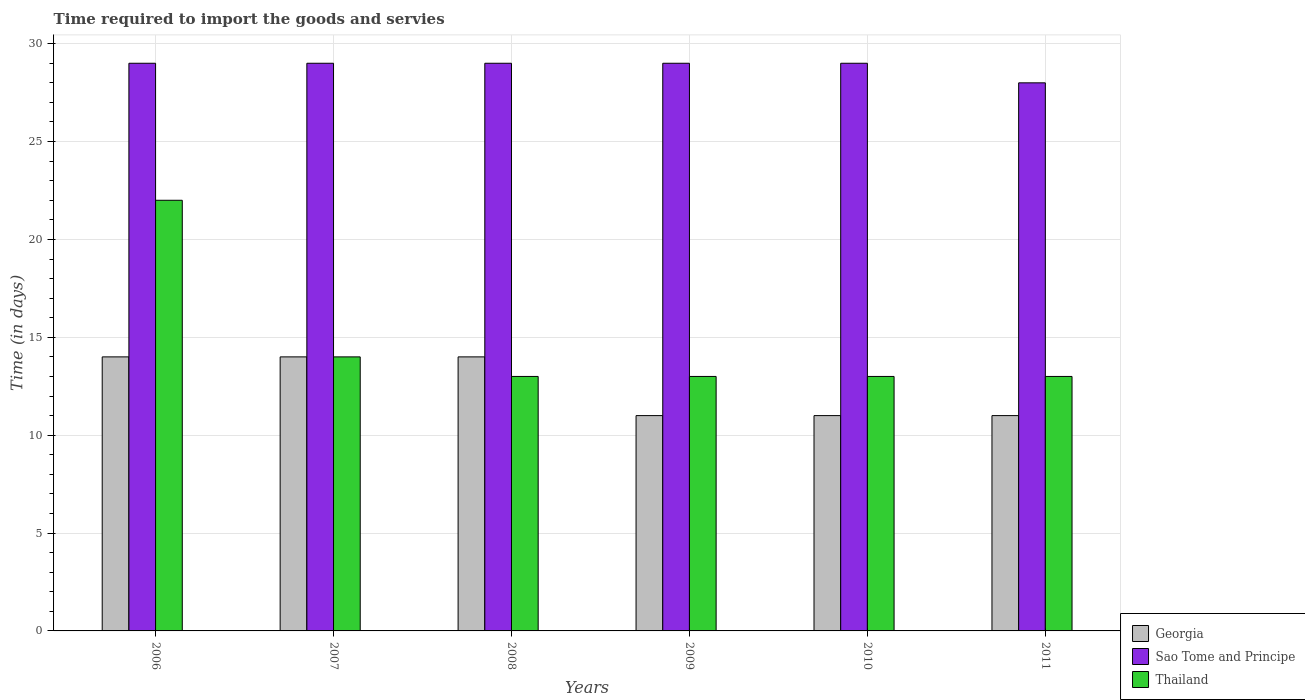How many different coloured bars are there?
Keep it short and to the point. 3. What is the label of the 4th group of bars from the left?
Make the answer very short. 2009. What is the number of days required to import the goods and services in Sao Tome and Principe in 2008?
Offer a very short reply. 29. Across all years, what is the maximum number of days required to import the goods and services in Thailand?
Keep it short and to the point. 22. Across all years, what is the minimum number of days required to import the goods and services in Thailand?
Your answer should be very brief. 13. What is the total number of days required to import the goods and services in Georgia in the graph?
Provide a short and direct response. 75. What is the difference between the number of days required to import the goods and services in Sao Tome and Principe in 2010 and that in 2011?
Your response must be concise. 1. What is the difference between the number of days required to import the goods and services in Sao Tome and Principe in 2011 and the number of days required to import the goods and services in Thailand in 2007?
Provide a short and direct response. 14. What is the average number of days required to import the goods and services in Thailand per year?
Your answer should be compact. 14.67. In the year 2010, what is the difference between the number of days required to import the goods and services in Georgia and number of days required to import the goods and services in Thailand?
Provide a succinct answer. -2. Is the number of days required to import the goods and services in Georgia in 2010 less than that in 2011?
Provide a short and direct response. No. Is the difference between the number of days required to import the goods and services in Georgia in 2008 and 2010 greater than the difference between the number of days required to import the goods and services in Thailand in 2008 and 2010?
Provide a succinct answer. Yes. What is the difference between the highest and the second highest number of days required to import the goods and services in Georgia?
Your answer should be compact. 0. What is the difference between the highest and the lowest number of days required to import the goods and services in Georgia?
Offer a terse response. 3. In how many years, is the number of days required to import the goods and services in Sao Tome and Principe greater than the average number of days required to import the goods and services in Sao Tome and Principe taken over all years?
Give a very brief answer. 5. Is the sum of the number of days required to import the goods and services in Sao Tome and Principe in 2006 and 2010 greater than the maximum number of days required to import the goods and services in Thailand across all years?
Keep it short and to the point. Yes. What does the 1st bar from the left in 2006 represents?
Your response must be concise. Georgia. What does the 2nd bar from the right in 2009 represents?
Offer a terse response. Sao Tome and Principe. How many years are there in the graph?
Your response must be concise. 6. What is the difference between two consecutive major ticks on the Y-axis?
Provide a succinct answer. 5. Does the graph contain grids?
Make the answer very short. Yes. Where does the legend appear in the graph?
Keep it short and to the point. Bottom right. How many legend labels are there?
Your answer should be very brief. 3. How are the legend labels stacked?
Your answer should be compact. Vertical. What is the title of the graph?
Offer a terse response. Time required to import the goods and servies. Does "Andorra" appear as one of the legend labels in the graph?
Provide a short and direct response. No. What is the label or title of the Y-axis?
Your answer should be very brief. Time (in days). What is the Time (in days) of Georgia in 2006?
Offer a very short reply. 14. What is the Time (in days) in Sao Tome and Principe in 2006?
Give a very brief answer. 29. What is the Time (in days) of Thailand in 2006?
Keep it short and to the point. 22. What is the Time (in days) of Thailand in 2008?
Give a very brief answer. 13. What is the Time (in days) of Sao Tome and Principe in 2009?
Give a very brief answer. 29. What is the Time (in days) in Sao Tome and Principe in 2010?
Give a very brief answer. 29. What is the Time (in days) of Thailand in 2010?
Provide a short and direct response. 13. What is the Time (in days) of Thailand in 2011?
Ensure brevity in your answer.  13. Across all years, what is the maximum Time (in days) of Sao Tome and Principe?
Provide a succinct answer. 29. Across all years, what is the maximum Time (in days) of Thailand?
Your answer should be compact. 22. Across all years, what is the minimum Time (in days) in Sao Tome and Principe?
Offer a very short reply. 28. What is the total Time (in days) of Sao Tome and Principe in the graph?
Provide a succinct answer. 173. What is the total Time (in days) in Thailand in the graph?
Your answer should be very brief. 88. What is the difference between the Time (in days) of Georgia in 2006 and that in 2008?
Make the answer very short. 0. What is the difference between the Time (in days) of Sao Tome and Principe in 2006 and that in 2008?
Keep it short and to the point. 0. What is the difference between the Time (in days) of Thailand in 2006 and that in 2008?
Offer a terse response. 9. What is the difference between the Time (in days) in Thailand in 2006 and that in 2010?
Offer a terse response. 9. What is the difference between the Time (in days) of Georgia in 2006 and that in 2011?
Your response must be concise. 3. What is the difference between the Time (in days) of Sao Tome and Principe in 2006 and that in 2011?
Give a very brief answer. 1. What is the difference between the Time (in days) of Georgia in 2007 and that in 2008?
Provide a short and direct response. 0. What is the difference between the Time (in days) in Sao Tome and Principe in 2007 and that in 2008?
Make the answer very short. 0. What is the difference between the Time (in days) of Thailand in 2007 and that in 2008?
Your answer should be compact. 1. What is the difference between the Time (in days) of Georgia in 2007 and that in 2009?
Your response must be concise. 3. What is the difference between the Time (in days) of Sao Tome and Principe in 2007 and that in 2009?
Give a very brief answer. 0. What is the difference between the Time (in days) in Georgia in 2007 and that in 2010?
Make the answer very short. 3. What is the difference between the Time (in days) of Thailand in 2007 and that in 2010?
Offer a terse response. 1. What is the difference between the Time (in days) of Georgia in 2007 and that in 2011?
Offer a terse response. 3. What is the difference between the Time (in days) of Sao Tome and Principe in 2007 and that in 2011?
Your answer should be compact. 1. What is the difference between the Time (in days) of Georgia in 2008 and that in 2009?
Your response must be concise. 3. What is the difference between the Time (in days) of Sao Tome and Principe in 2008 and that in 2009?
Make the answer very short. 0. What is the difference between the Time (in days) of Thailand in 2008 and that in 2009?
Your answer should be very brief. 0. What is the difference between the Time (in days) in Sao Tome and Principe in 2008 and that in 2010?
Ensure brevity in your answer.  0. What is the difference between the Time (in days) in Thailand in 2008 and that in 2010?
Give a very brief answer. 0. What is the difference between the Time (in days) of Sao Tome and Principe in 2008 and that in 2011?
Your response must be concise. 1. What is the difference between the Time (in days) of Thailand in 2008 and that in 2011?
Make the answer very short. 0. What is the difference between the Time (in days) in Sao Tome and Principe in 2009 and that in 2010?
Keep it short and to the point. 0. What is the difference between the Time (in days) of Georgia in 2009 and that in 2011?
Give a very brief answer. 0. What is the difference between the Time (in days) in Sao Tome and Principe in 2009 and that in 2011?
Your answer should be compact. 1. What is the difference between the Time (in days) in Thailand in 2009 and that in 2011?
Your response must be concise. 0. What is the difference between the Time (in days) of Sao Tome and Principe in 2010 and that in 2011?
Ensure brevity in your answer.  1. What is the difference between the Time (in days) in Georgia in 2006 and the Time (in days) in Thailand in 2008?
Provide a short and direct response. 1. What is the difference between the Time (in days) in Sao Tome and Principe in 2006 and the Time (in days) in Thailand in 2009?
Make the answer very short. 16. What is the difference between the Time (in days) of Sao Tome and Principe in 2006 and the Time (in days) of Thailand in 2010?
Provide a short and direct response. 16. What is the difference between the Time (in days) in Georgia in 2006 and the Time (in days) in Sao Tome and Principe in 2011?
Keep it short and to the point. -14. What is the difference between the Time (in days) of Georgia in 2007 and the Time (in days) of Sao Tome and Principe in 2008?
Provide a short and direct response. -15. What is the difference between the Time (in days) in Sao Tome and Principe in 2007 and the Time (in days) in Thailand in 2009?
Your answer should be compact. 16. What is the difference between the Time (in days) in Georgia in 2007 and the Time (in days) in Thailand in 2010?
Ensure brevity in your answer.  1. What is the difference between the Time (in days) in Sao Tome and Principe in 2007 and the Time (in days) in Thailand in 2010?
Your answer should be very brief. 16. What is the difference between the Time (in days) of Sao Tome and Principe in 2007 and the Time (in days) of Thailand in 2011?
Provide a short and direct response. 16. What is the difference between the Time (in days) in Georgia in 2008 and the Time (in days) in Sao Tome and Principe in 2009?
Offer a very short reply. -15. What is the difference between the Time (in days) of Georgia in 2008 and the Time (in days) of Sao Tome and Principe in 2010?
Make the answer very short. -15. What is the difference between the Time (in days) of Sao Tome and Principe in 2008 and the Time (in days) of Thailand in 2010?
Your answer should be compact. 16. What is the difference between the Time (in days) in Georgia in 2008 and the Time (in days) in Sao Tome and Principe in 2011?
Make the answer very short. -14. What is the difference between the Time (in days) in Georgia in 2008 and the Time (in days) in Thailand in 2011?
Your answer should be compact. 1. What is the difference between the Time (in days) of Georgia in 2009 and the Time (in days) of Sao Tome and Principe in 2010?
Your answer should be compact. -18. What is the difference between the Time (in days) of Georgia in 2009 and the Time (in days) of Thailand in 2010?
Offer a terse response. -2. What is the difference between the Time (in days) of Georgia in 2009 and the Time (in days) of Sao Tome and Principe in 2011?
Ensure brevity in your answer.  -17. What is the difference between the Time (in days) of Sao Tome and Principe in 2009 and the Time (in days) of Thailand in 2011?
Provide a short and direct response. 16. What is the difference between the Time (in days) of Sao Tome and Principe in 2010 and the Time (in days) of Thailand in 2011?
Give a very brief answer. 16. What is the average Time (in days) in Sao Tome and Principe per year?
Your response must be concise. 28.83. What is the average Time (in days) in Thailand per year?
Your answer should be very brief. 14.67. In the year 2006, what is the difference between the Time (in days) in Georgia and Time (in days) in Sao Tome and Principe?
Offer a terse response. -15. In the year 2007, what is the difference between the Time (in days) in Georgia and Time (in days) in Thailand?
Your answer should be very brief. 0. In the year 2008, what is the difference between the Time (in days) in Georgia and Time (in days) in Thailand?
Offer a terse response. 1. In the year 2009, what is the difference between the Time (in days) of Georgia and Time (in days) of Sao Tome and Principe?
Provide a short and direct response. -18. In the year 2010, what is the difference between the Time (in days) in Sao Tome and Principe and Time (in days) in Thailand?
Offer a terse response. 16. In the year 2011, what is the difference between the Time (in days) of Georgia and Time (in days) of Sao Tome and Principe?
Keep it short and to the point. -17. What is the ratio of the Time (in days) of Thailand in 2006 to that in 2007?
Your answer should be very brief. 1.57. What is the ratio of the Time (in days) in Georgia in 2006 to that in 2008?
Provide a succinct answer. 1. What is the ratio of the Time (in days) in Sao Tome and Principe in 2006 to that in 2008?
Your answer should be compact. 1. What is the ratio of the Time (in days) of Thailand in 2006 to that in 2008?
Give a very brief answer. 1.69. What is the ratio of the Time (in days) in Georgia in 2006 to that in 2009?
Your answer should be very brief. 1.27. What is the ratio of the Time (in days) in Thailand in 2006 to that in 2009?
Provide a succinct answer. 1.69. What is the ratio of the Time (in days) in Georgia in 2006 to that in 2010?
Offer a terse response. 1.27. What is the ratio of the Time (in days) of Sao Tome and Principe in 2006 to that in 2010?
Your response must be concise. 1. What is the ratio of the Time (in days) in Thailand in 2006 to that in 2010?
Your answer should be compact. 1.69. What is the ratio of the Time (in days) of Georgia in 2006 to that in 2011?
Your answer should be very brief. 1.27. What is the ratio of the Time (in days) in Sao Tome and Principe in 2006 to that in 2011?
Provide a short and direct response. 1.04. What is the ratio of the Time (in days) of Thailand in 2006 to that in 2011?
Provide a succinct answer. 1.69. What is the ratio of the Time (in days) of Georgia in 2007 to that in 2008?
Ensure brevity in your answer.  1. What is the ratio of the Time (in days) in Sao Tome and Principe in 2007 to that in 2008?
Provide a short and direct response. 1. What is the ratio of the Time (in days) of Thailand in 2007 to that in 2008?
Provide a succinct answer. 1.08. What is the ratio of the Time (in days) in Georgia in 2007 to that in 2009?
Offer a very short reply. 1.27. What is the ratio of the Time (in days) of Sao Tome and Principe in 2007 to that in 2009?
Give a very brief answer. 1. What is the ratio of the Time (in days) of Thailand in 2007 to that in 2009?
Your response must be concise. 1.08. What is the ratio of the Time (in days) of Georgia in 2007 to that in 2010?
Your answer should be compact. 1.27. What is the ratio of the Time (in days) of Georgia in 2007 to that in 2011?
Offer a very short reply. 1.27. What is the ratio of the Time (in days) of Sao Tome and Principe in 2007 to that in 2011?
Offer a very short reply. 1.04. What is the ratio of the Time (in days) in Georgia in 2008 to that in 2009?
Your answer should be compact. 1.27. What is the ratio of the Time (in days) in Sao Tome and Principe in 2008 to that in 2009?
Keep it short and to the point. 1. What is the ratio of the Time (in days) of Georgia in 2008 to that in 2010?
Offer a terse response. 1.27. What is the ratio of the Time (in days) of Thailand in 2008 to that in 2010?
Your answer should be very brief. 1. What is the ratio of the Time (in days) in Georgia in 2008 to that in 2011?
Provide a succinct answer. 1.27. What is the ratio of the Time (in days) of Sao Tome and Principe in 2008 to that in 2011?
Ensure brevity in your answer.  1.04. What is the ratio of the Time (in days) in Sao Tome and Principe in 2009 to that in 2010?
Provide a succinct answer. 1. What is the ratio of the Time (in days) in Sao Tome and Principe in 2009 to that in 2011?
Make the answer very short. 1.04. What is the ratio of the Time (in days) in Thailand in 2009 to that in 2011?
Offer a terse response. 1. What is the ratio of the Time (in days) of Sao Tome and Principe in 2010 to that in 2011?
Your answer should be compact. 1.04. What is the difference between the highest and the second highest Time (in days) of Georgia?
Provide a succinct answer. 0. What is the difference between the highest and the second highest Time (in days) in Sao Tome and Principe?
Make the answer very short. 0. What is the difference between the highest and the second highest Time (in days) of Thailand?
Provide a succinct answer. 8. What is the difference between the highest and the lowest Time (in days) in Georgia?
Give a very brief answer. 3. 